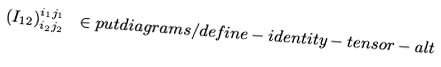Convert formula to latex. <formula><loc_0><loc_0><loc_500><loc_500>( I _ { 1 2 } ) ^ { i _ { 1 } j _ { 1 } } _ { i _ { 2 } j _ { 2 } } \ \in p u t { d i a g r a m s / d e f i n e - i d e n t i t y - t e n s o r - a l t }</formula> 